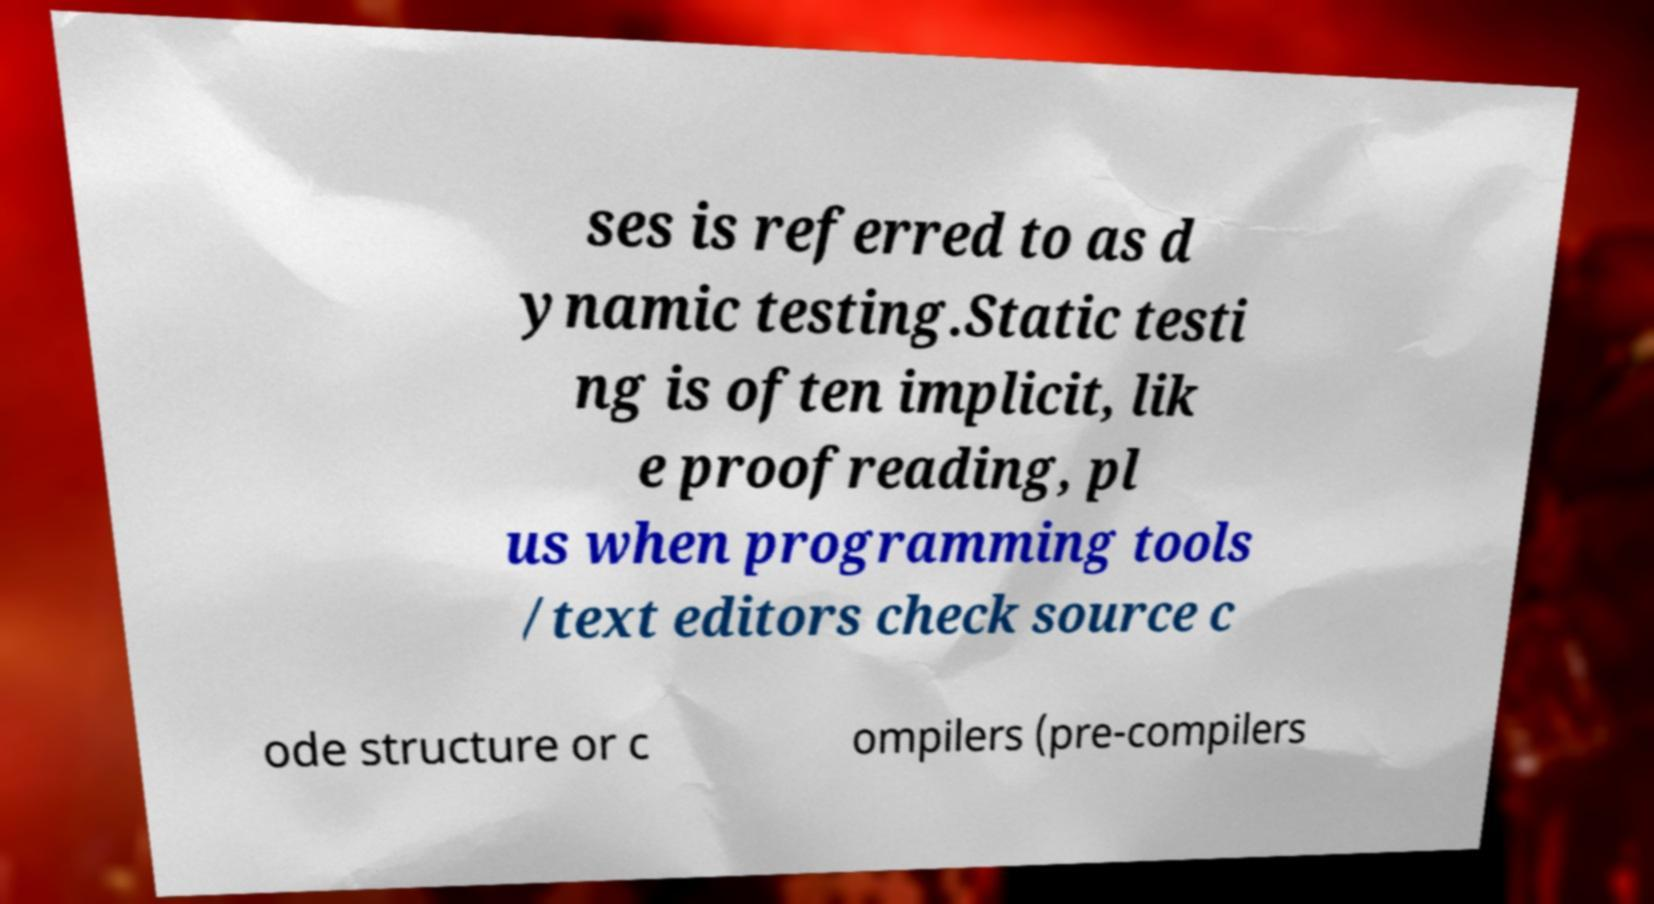Could you extract and type out the text from this image? ses is referred to as d ynamic testing.Static testi ng is often implicit, lik e proofreading, pl us when programming tools /text editors check source c ode structure or c ompilers (pre-compilers 